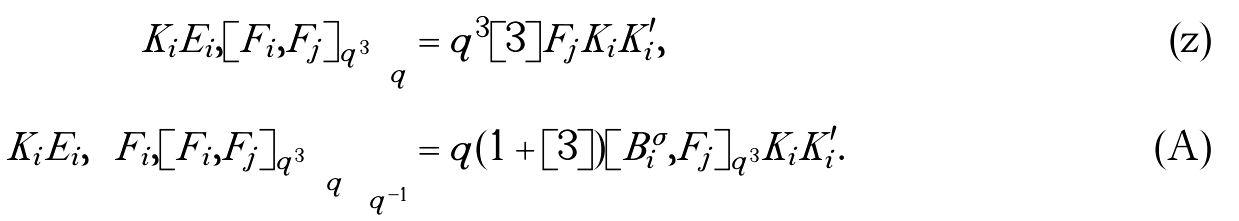Convert formula to latex. <formula><loc_0><loc_0><loc_500><loc_500>\left [ K _ { i } E _ { i } , [ F _ { i } , F _ { j } ] _ { q ^ { 3 } } \right ] _ { q } & = q ^ { 3 } [ 3 ] F _ { j } K _ { i } K _ { i } ^ { \prime } , \\ \left [ K _ { i } E _ { i } , \left [ F _ { i } , [ F _ { i } , F _ { j } ] _ { q ^ { 3 } } \right ] _ { q } \right ] _ { q ^ { - 1 } } & = q ( 1 + [ 3 ] ) [ B _ { i } ^ { \sigma } , F _ { j } ] _ { q ^ { 3 } } K _ { i } K _ { i } ^ { \prime } .</formula> 